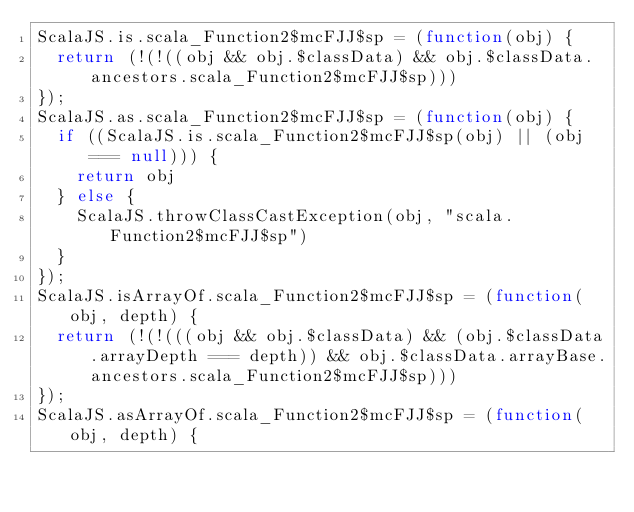<code> <loc_0><loc_0><loc_500><loc_500><_JavaScript_>ScalaJS.is.scala_Function2$mcFJJ$sp = (function(obj) {
  return (!(!((obj && obj.$classData) && obj.$classData.ancestors.scala_Function2$mcFJJ$sp)))
});
ScalaJS.as.scala_Function2$mcFJJ$sp = (function(obj) {
  if ((ScalaJS.is.scala_Function2$mcFJJ$sp(obj) || (obj === null))) {
    return obj
  } else {
    ScalaJS.throwClassCastException(obj, "scala.Function2$mcFJJ$sp")
  }
});
ScalaJS.isArrayOf.scala_Function2$mcFJJ$sp = (function(obj, depth) {
  return (!(!(((obj && obj.$classData) && (obj.$classData.arrayDepth === depth)) && obj.$classData.arrayBase.ancestors.scala_Function2$mcFJJ$sp)))
});
ScalaJS.asArrayOf.scala_Function2$mcFJJ$sp = (function(obj, depth) {</code> 